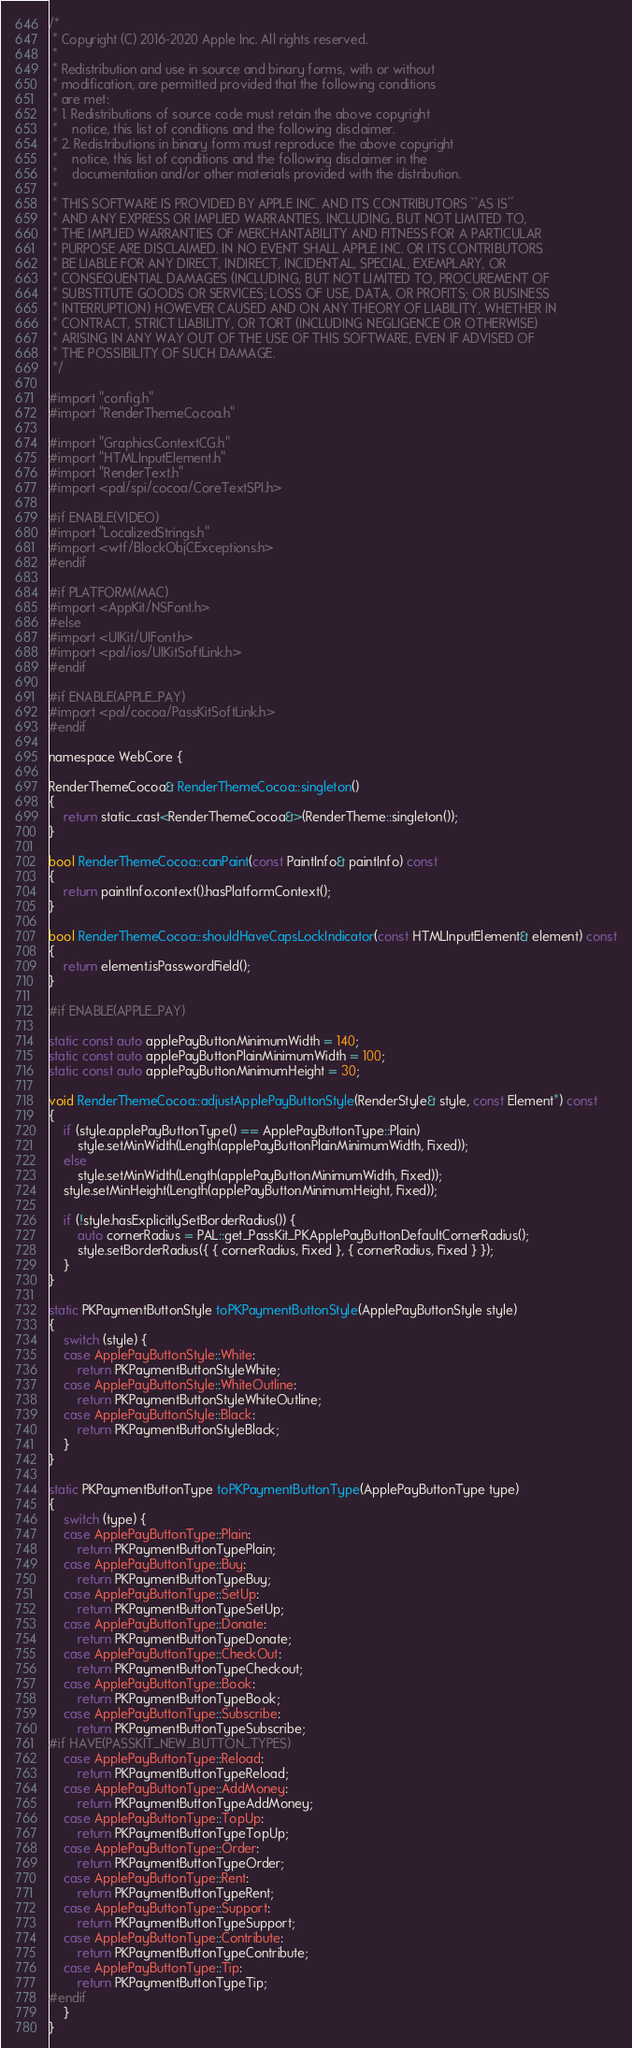Convert code to text. <code><loc_0><loc_0><loc_500><loc_500><_ObjectiveC_>/*
 * Copyright (C) 2016-2020 Apple Inc. All rights reserved.
 *
 * Redistribution and use in source and binary forms, with or without
 * modification, are permitted provided that the following conditions
 * are met:
 * 1. Redistributions of source code must retain the above copyright
 *    notice, this list of conditions and the following disclaimer.
 * 2. Redistributions in binary form must reproduce the above copyright
 *    notice, this list of conditions and the following disclaimer in the
 *    documentation and/or other materials provided with the distribution.
 *
 * THIS SOFTWARE IS PROVIDED BY APPLE INC. AND ITS CONTRIBUTORS ``AS IS''
 * AND ANY EXPRESS OR IMPLIED WARRANTIES, INCLUDING, BUT NOT LIMITED TO,
 * THE IMPLIED WARRANTIES OF MERCHANTABILITY AND FITNESS FOR A PARTICULAR
 * PURPOSE ARE DISCLAIMED. IN NO EVENT SHALL APPLE INC. OR ITS CONTRIBUTORS
 * BE LIABLE FOR ANY DIRECT, INDIRECT, INCIDENTAL, SPECIAL, EXEMPLARY, OR
 * CONSEQUENTIAL DAMAGES (INCLUDING, BUT NOT LIMITED TO, PROCUREMENT OF
 * SUBSTITUTE GOODS OR SERVICES; LOSS OF USE, DATA, OR PROFITS; OR BUSINESS
 * INTERRUPTION) HOWEVER CAUSED AND ON ANY THEORY OF LIABILITY, WHETHER IN
 * CONTRACT, STRICT LIABILITY, OR TORT (INCLUDING NEGLIGENCE OR OTHERWISE)
 * ARISING IN ANY WAY OUT OF THE USE OF THIS SOFTWARE, EVEN IF ADVISED OF
 * THE POSSIBILITY OF SUCH DAMAGE.
 */

#import "config.h"
#import "RenderThemeCocoa.h"

#import "GraphicsContextCG.h"
#import "HTMLInputElement.h"
#import "RenderText.h"
#import <pal/spi/cocoa/CoreTextSPI.h>

#if ENABLE(VIDEO)
#import "LocalizedStrings.h"
#import <wtf/BlockObjCExceptions.h>
#endif

#if PLATFORM(MAC)
#import <AppKit/NSFont.h>
#else
#import <UIKit/UIFont.h>
#import <pal/ios/UIKitSoftLink.h>
#endif

#if ENABLE(APPLE_PAY)
#import <pal/cocoa/PassKitSoftLink.h>
#endif

namespace WebCore {

RenderThemeCocoa& RenderThemeCocoa::singleton()
{
    return static_cast<RenderThemeCocoa&>(RenderTheme::singleton());
}

bool RenderThemeCocoa::canPaint(const PaintInfo& paintInfo) const
{
    return paintInfo.context().hasPlatformContext();
}

bool RenderThemeCocoa::shouldHaveCapsLockIndicator(const HTMLInputElement& element) const
{
    return element.isPasswordField();
}

#if ENABLE(APPLE_PAY)

static const auto applePayButtonMinimumWidth = 140;
static const auto applePayButtonPlainMinimumWidth = 100;
static const auto applePayButtonMinimumHeight = 30;

void RenderThemeCocoa::adjustApplePayButtonStyle(RenderStyle& style, const Element*) const
{
    if (style.applePayButtonType() == ApplePayButtonType::Plain)
        style.setMinWidth(Length(applePayButtonPlainMinimumWidth, Fixed));
    else
        style.setMinWidth(Length(applePayButtonMinimumWidth, Fixed));
    style.setMinHeight(Length(applePayButtonMinimumHeight, Fixed));

    if (!style.hasExplicitlySetBorderRadius()) {
        auto cornerRadius = PAL::get_PassKit_PKApplePayButtonDefaultCornerRadius();
        style.setBorderRadius({ { cornerRadius, Fixed }, { cornerRadius, Fixed } });
    }
}

static PKPaymentButtonStyle toPKPaymentButtonStyle(ApplePayButtonStyle style)
{
    switch (style) {
    case ApplePayButtonStyle::White:
        return PKPaymentButtonStyleWhite;
    case ApplePayButtonStyle::WhiteOutline:
        return PKPaymentButtonStyleWhiteOutline;
    case ApplePayButtonStyle::Black:
        return PKPaymentButtonStyleBlack;
    }
}

static PKPaymentButtonType toPKPaymentButtonType(ApplePayButtonType type)
{
    switch (type) {
    case ApplePayButtonType::Plain:
        return PKPaymentButtonTypePlain;
    case ApplePayButtonType::Buy:
        return PKPaymentButtonTypeBuy;
    case ApplePayButtonType::SetUp:
        return PKPaymentButtonTypeSetUp;
    case ApplePayButtonType::Donate:
        return PKPaymentButtonTypeDonate;
    case ApplePayButtonType::CheckOut:
        return PKPaymentButtonTypeCheckout;
    case ApplePayButtonType::Book:
        return PKPaymentButtonTypeBook;
    case ApplePayButtonType::Subscribe:
        return PKPaymentButtonTypeSubscribe;
#if HAVE(PASSKIT_NEW_BUTTON_TYPES)
    case ApplePayButtonType::Reload:
        return PKPaymentButtonTypeReload;
    case ApplePayButtonType::AddMoney:
        return PKPaymentButtonTypeAddMoney;
    case ApplePayButtonType::TopUp:
        return PKPaymentButtonTypeTopUp;
    case ApplePayButtonType::Order:
        return PKPaymentButtonTypeOrder;
    case ApplePayButtonType::Rent:
        return PKPaymentButtonTypeRent;
    case ApplePayButtonType::Support:
        return PKPaymentButtonTypeSupport;
    case ApplePayButtonType::Contribute:
        return PKPaymentButtonTypeContribute;
    case ApplePayButtonType::Tip:
        return PKPaymentButtonTypeTip;
#endif
    }
}
</code> 